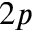<formula> <loc_0><loc_0><loc_500><loc_500>2 p</formula> 